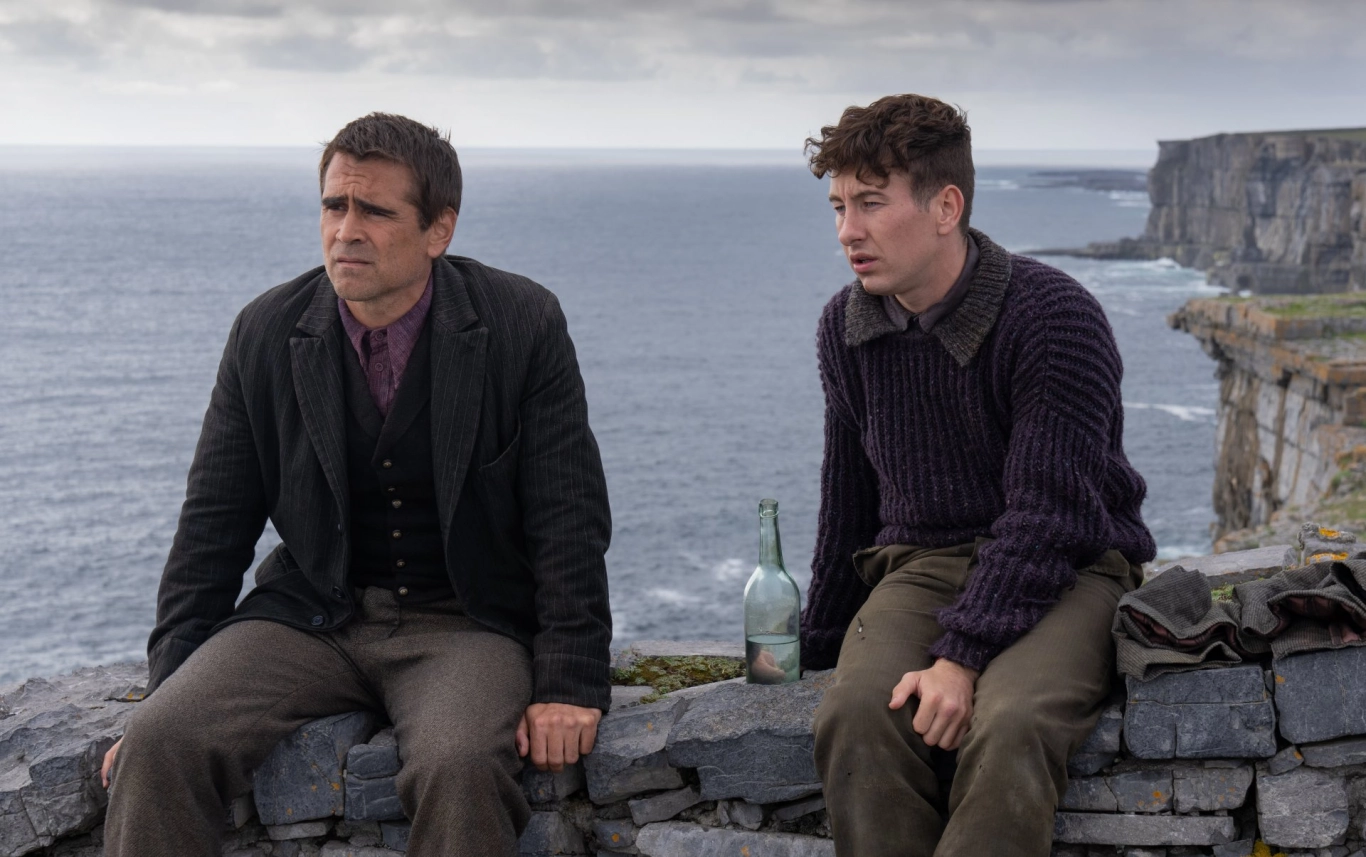Describe the mood and atmosphere of this image in detail. The mood of the image is a blend of solemn introspection and serene contemplation. The two individuals' serious expressions and their focused gaze into the distance suggest that they are lost in deep thought, perhaps pondering the significant decisions or reflecting on past events. The overcast sky and the setting on the edge of a cliff overlooking the endless ocean enhance the feeling of solitude and introspection. The natural elements like the rugged cliffs, the rough stone wall, and the restless ocean waves contribute to a gritty, raw beauty. Overall, the atmosphere is intense yet calm, evoking a sense of peace intertwined with emotional depth. Imagine if these two characters were part of a fantasy world. How would their journey be different? In a fantasy world, Liam and Jack might be adventurers on a quest to discover ancient relics or unravel long-lost secrets. The stone wall they sit on could be the edge of an enchanted cliff, where the ocean below holds mythical creatures and hidden treasures. Instead of a simple bottle, they might have a magical potion that grants them temporary insight into future events, and the backpack could contain scrolls of forbidden spells or maps leading to uncharted territories. Their journey would be fraught with challenges from mythical beasts, enchanted forests, and rival adventurers, each step a test of their skills, courage, and friendship. 